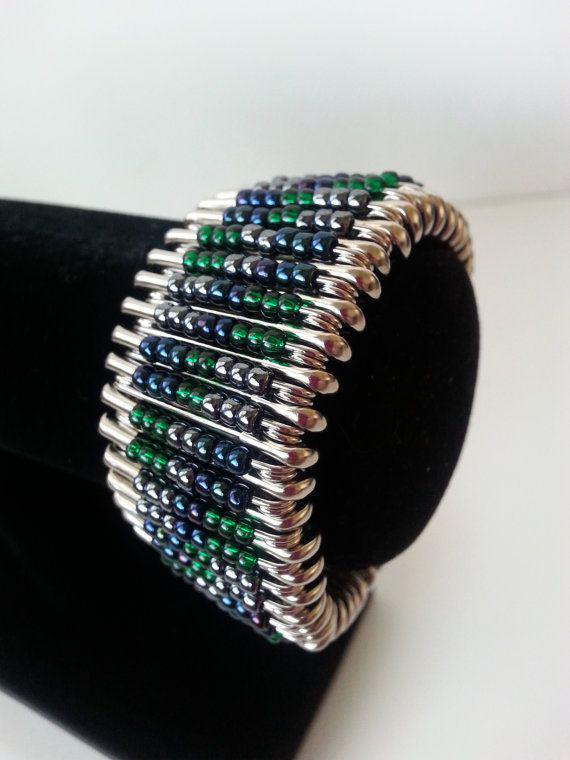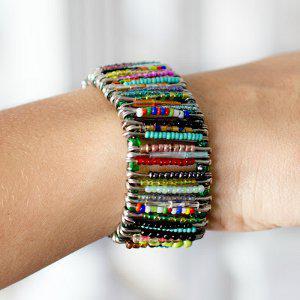The first image is the image on the left, the second image is the image on the right. Assess this claim about the two images: "There are two unworn bracelets". Correct or not? Answer yes or no. No. 